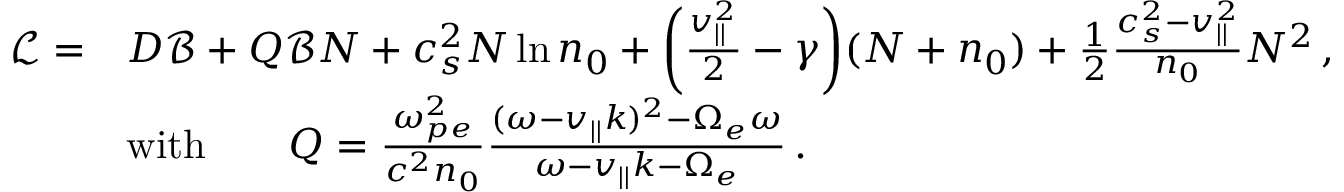Convert formula to latex. <formula><loc_0><loc_0><loc_500><loc_500>\begin{array} { r l } { \ m a t h s c r { L } = } & { D \ m a t h s c r { B } + Q \ m a t h s c r { B } N + c _ { s } ^ { 2 } N \ln n _ { 0 } + \left ( \frac { v _ { | | } ^ { 2 } } { 2 } - \gamma \right ) ( N + n _ { 0 } ) + \frac { 1 } { 2 } \frac { c _ { s } ^ { 2 } - v _ { | | } ^ { 2 } } { n _ { 0 } } N ^ { 2 } \, , } \\ & { w i t h \quad Q = \frac { \omega _ { p e } ^ { 2 } } { c ^ { 2 } n _ { 0 } } \frac { ( \omega - v _ { | | } k ) ^ { 2 } - \Omega _ { e } \omega } { \omega - v _ { | | } k - \Omega _ { e } } \, . } \end{array}</formula> 